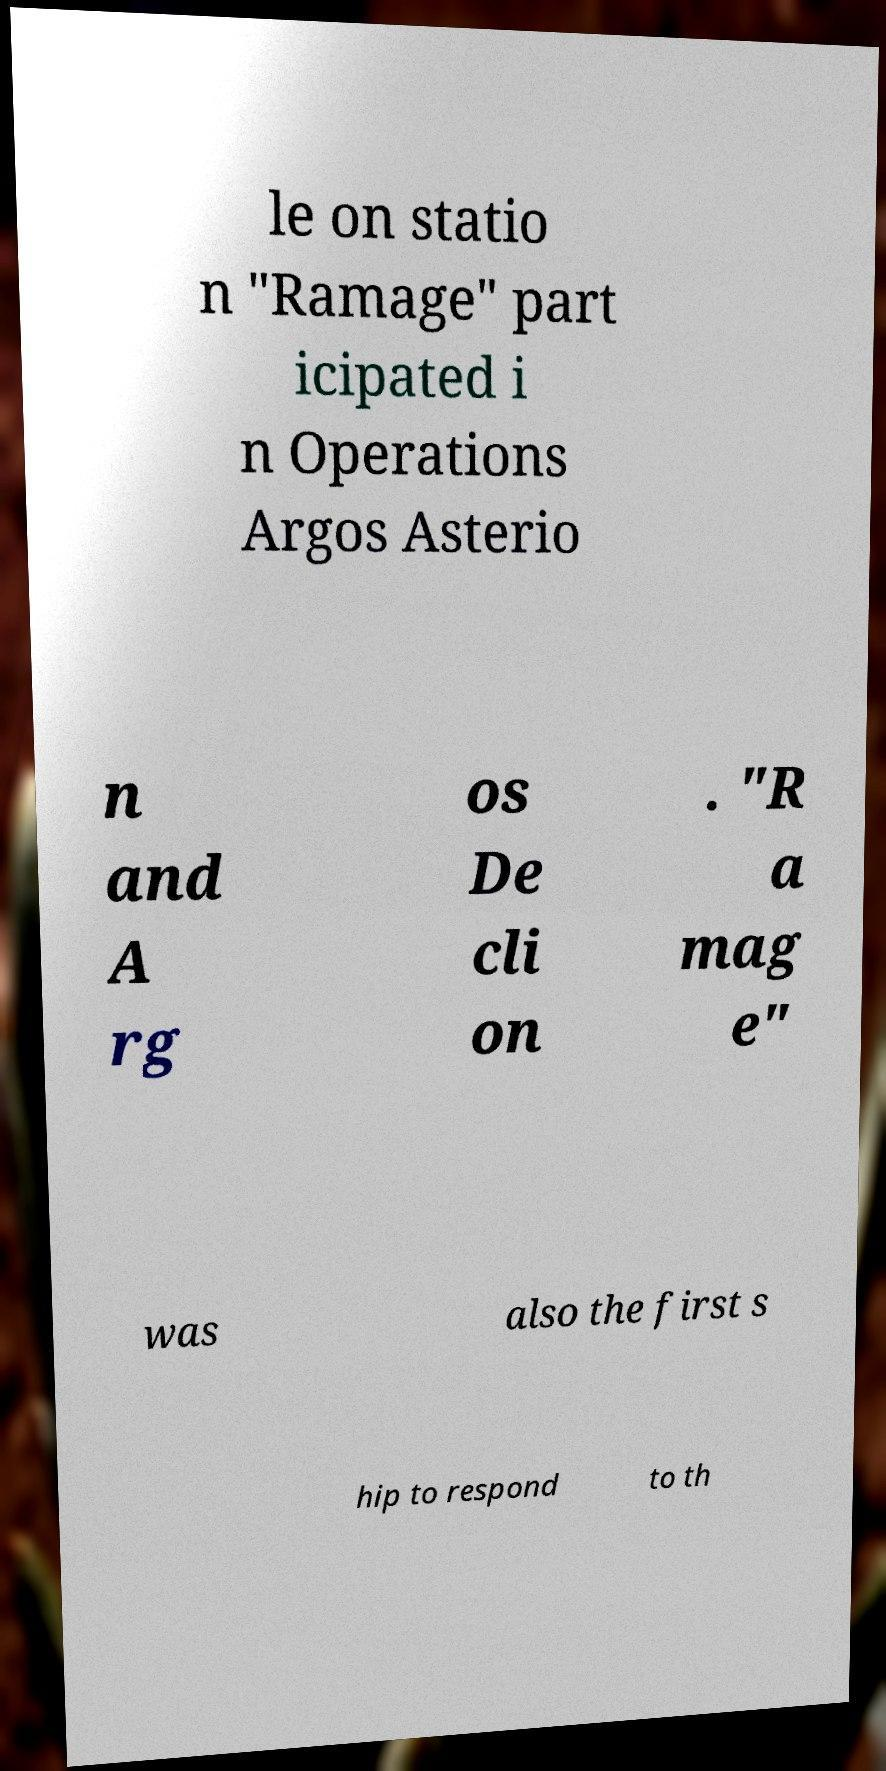Can you read and provide the text displayed in the image?This photo seems to have some interesting text. Can you extract and type it out for me? le on statio n "Ramage" part icipated i n Operations Argos Asterio n and A rg os De cli on . "R a mag e" was also the first s hip to respond to th 